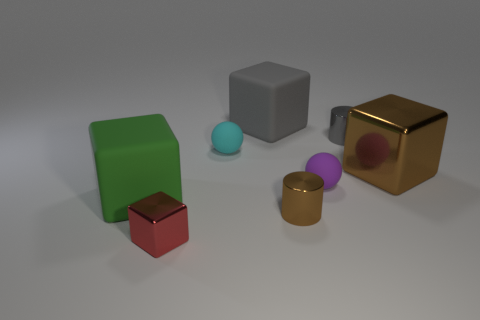There is a cyan thing that is on the left side of the big brown block; is it the same size as the brown object that is behind the green rubber block?
Make the answer very short. No. What is the size of the gray object that is the same material as the cyan ball?
Make the answer very short. Large. How many big cubes are both left of the purple matte ball and behind the green cube?
Make the answer very short. 1. How many things are brown shiny cylinders or small cyan matte objects to the left of the small purple thing?
Give a very brief answer. 2. There is another thing that is the same color as the large metal object; what is its shape?
Your response must be concise. Cylinder. There is a small rubber object left of the gray matte cube; what color is it?
Your answer should be very brief. Cyan. What number of things are either matte objects to the left of the small red metallic thing or tiny gray metal cylinders?
Your answer should be compact. 2. What is the color of the rubber block that is the same size as the gray matte object?
Offer a terse response. Green. Are there more small gray metallic objects left of the big green rubber thing than small cylinders?
Your answer should be very brief. No. What is the big thing that is left of the large brown cube and in front of the cyan matte object made of?
Keep it short and to the point. Rubber. 